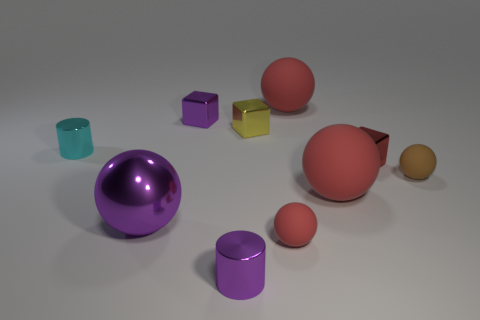What can you infer about the texture of the surfaces of these objects? The objects seem to have different textures. The spheres and the cylinders reflect more light, suggesting they have smoother and perhaps metallic surfaces. On the other hand, the cubes, particularly the purple one, appear to have a matte finish, absorbing more light and reflecting less, indicating a possibly rougher texture. 